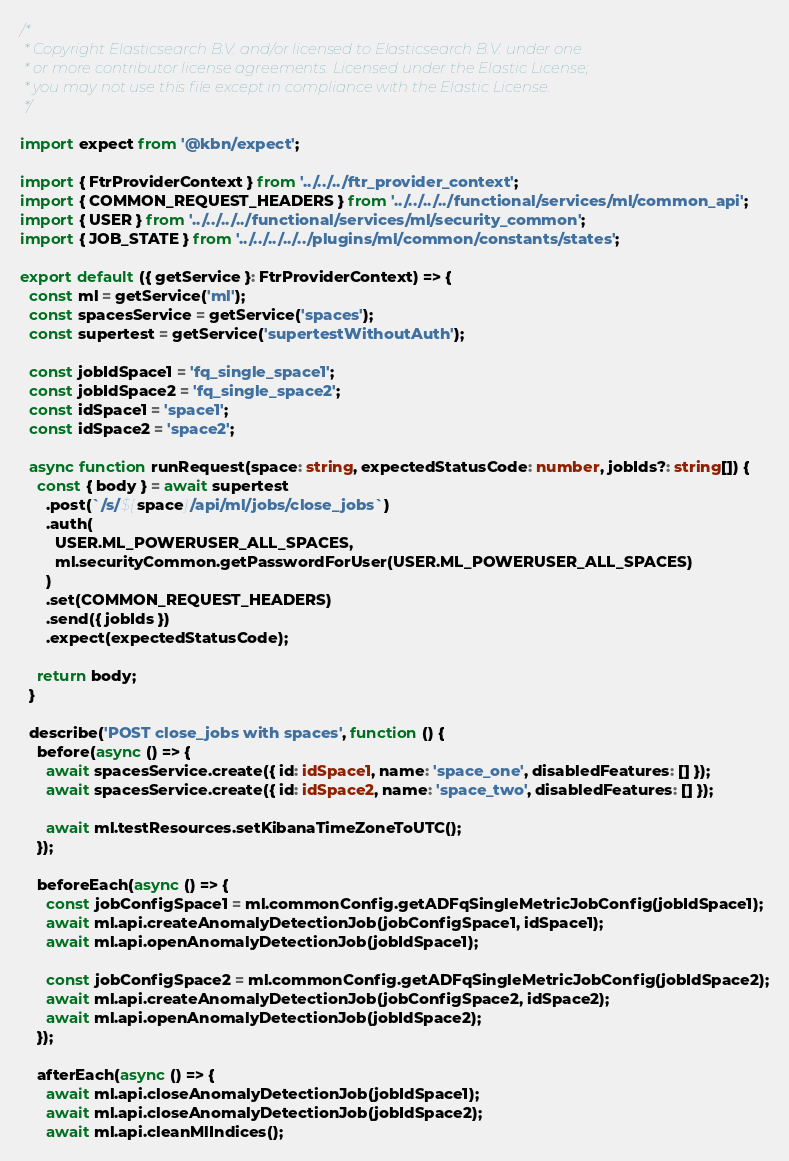<code> <loc_0><loc_0><loc_500><loc_500><_TypeScript_>/*
 * Copyright Elasticsearch B.V. and/or licensed to Elasticsearch B.V. under one
 * or more contributor license agreements. Licensed under the Elastic License;
 * you may not use this file except in compliance with the Elastic License.
 */

import expect from '@kbn/expect';

import { FtrProviderContext } from '../../../ftr_provider_context';
import { COMMON_REQUEST_HEADERS } from '../../../../functional/services/ml/common_api';
import { USER } from '../../../../functional/services/ml/security_common';
import { JOB_STATE } from '../../../../../plugins/ml/common/constants/states';

export default ({ getService }: FtrProviderContext) => {
  const ml = getService('ml');
  const spacesService = getService('spaces');
  const supertest = getService('supertestWithoutAuth');

  const jobIdSpace1 = 'fq_single_space1';
  const jobIdSpace2 = 'fq_single_space2';
  const idSpace1 = 'space1';
  const idSpace2 = 'space2';

  async function runRequest(space: string, expectedStatusCode: number, jobIds?: string[]) {
    const { body } = await supertest
      .post(`/s/${space}/api/ml/jobs/close_jobs`)
      .auth(
        USER.ML_POWERUSER_ALL_SPACES,
        ml.securityCommon.getPasswordForUser(USER.ML_POWERUSER_ALL_SPACES)
      )
      .set(COMMON_REQUEST_HEADERS)
      .send({ jobIds })
      .expect(expectedStatusCode);

    return body;
  }

  describe('POST close_jobs with spaces', function () {
    before(async () => {
      await spacesService.create({ id: idSpace1, name: 'space_one', disabledFeatures: [] });
      await spacesService.create({ id: idSpace2, name: 'space_two', disabledFeatures: [] });

      await ml.testResources.setKibanaTimeZoneToUTC();
    });

    beforeEach(async () => {
      const jobConfigSpace1 = ml.commonConfig.getADFqSingleMetricJobConfig(jobIdSpace1);
      await ml.api.createAnomalyDetectionJob(jobConfigSpace1, idSpace1);
      await ml.api.openAnomalyDetectionJob(jobIdSpace1);

      const jobConfigSpace2 = ml.commonConfig.getADFqSingleMetricJobConfig(jobIdSpace2);
      await ml.api.createAnomalyDetectionJob(jobConfigSpace2, idSpace2);
      await ml.api.openAnomalyDetectionJob(jobIdSpace2);
    });

    afterEach(async () => {
      await ml.api.closeAnomalyDetectionJob(jobIdSpace1);
      await ml.api.closeAnomalyDetectionJob(jobIdSpace2);
      await ml.api.cleanMlIndices();</code> 